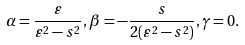<formula> <loc_0><loc_0><loc_500><loc_500>\alpha = \frac { \varepsilon } { \varepsilon ^ { 2 } - s ^ { 2 } } , \beta = - \frac { s } { 2 ( \varepsilon ^ { 2 } - s ^ { 2 } ) } , \gamma = 0 .</formula> 